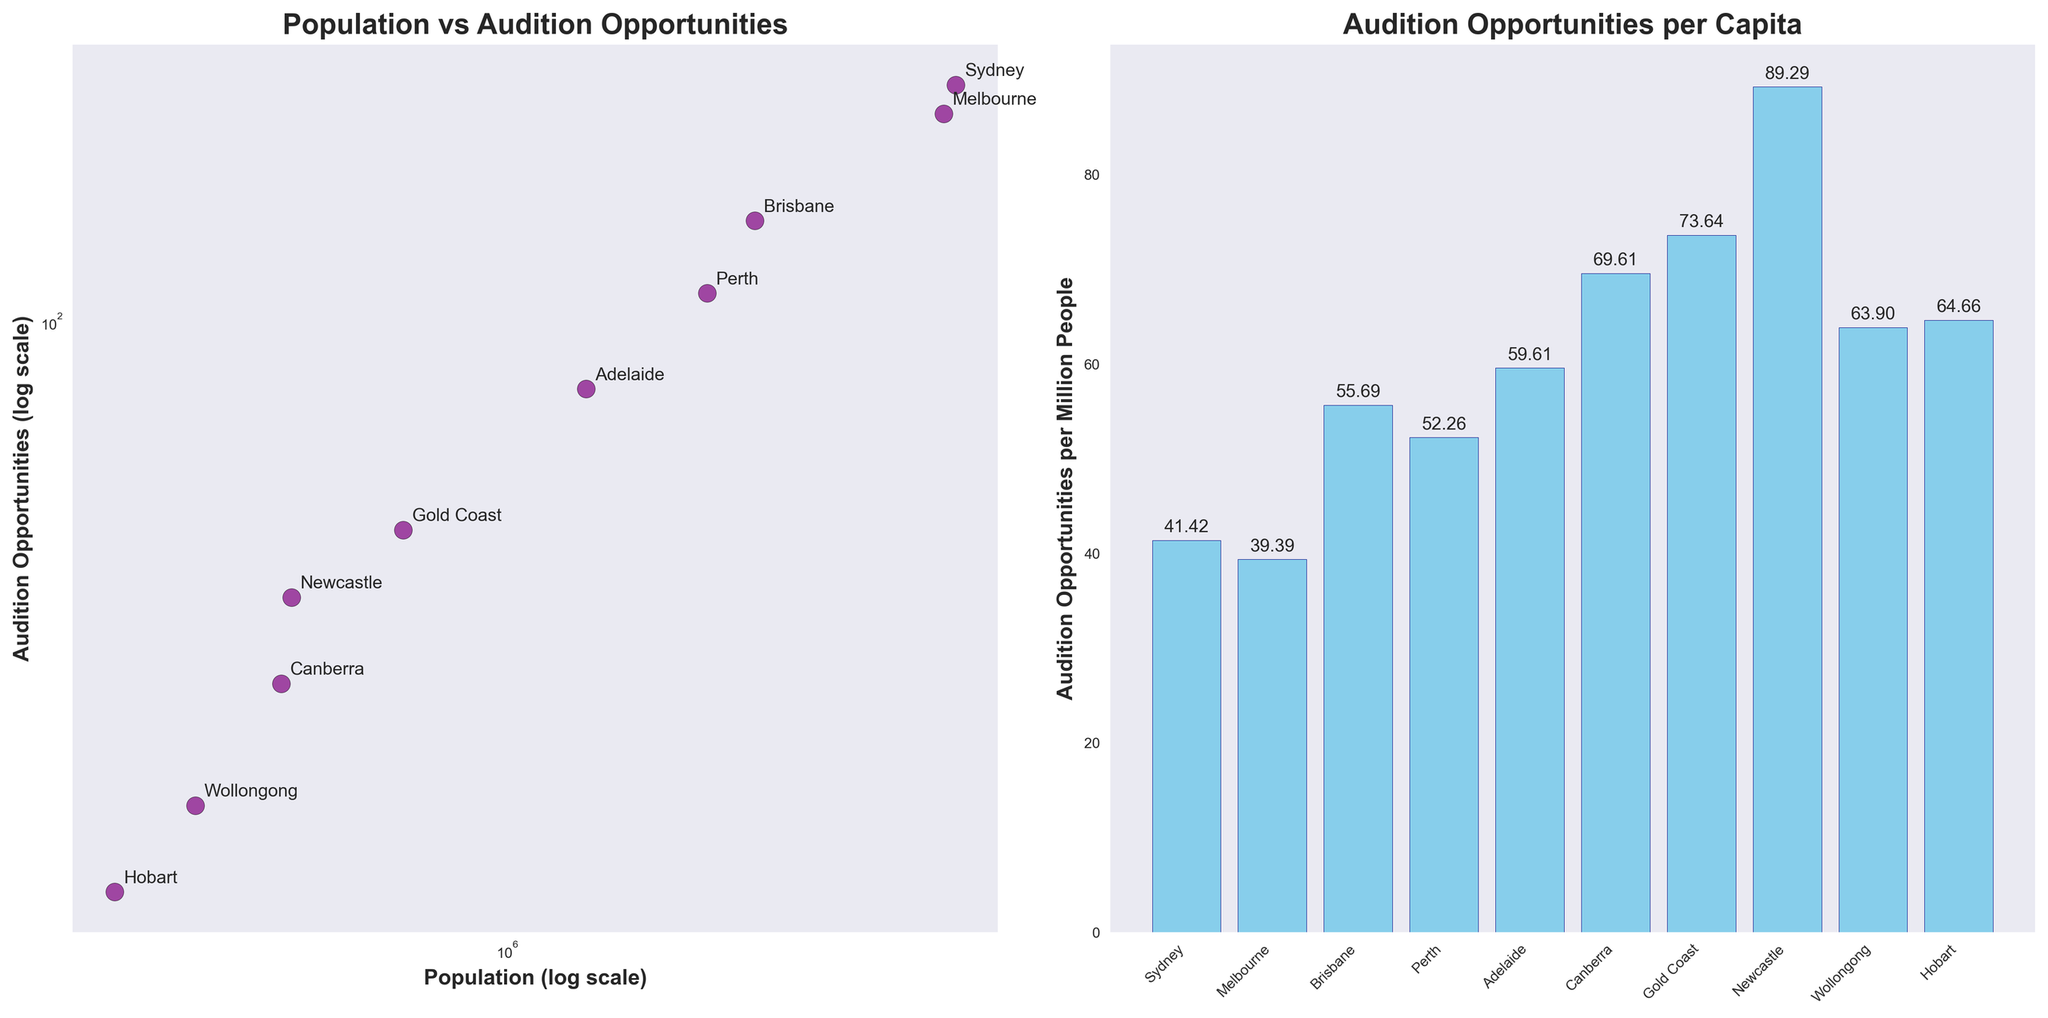Which city has the highest population? The left subplot shows population on the x-axis. From the data points, Sydney has the highest population by being furthest to the right.
Answer: Sydney How many cities have more than 100 audition opportunities? The left subplot uses a log scale. The cities above 100 on the y-axis are Sydney, Melbourne, Brisbane, and Perth.
Answer: 4 Which city has the highest auditions per capita? The right subplot shows audition opportunities per capita. Canberra has the highest bar, indicating the highest auditions per capita.
Answer: Canberra Which city has the lowest audition opportunities per capita? The right subplot indicates Hobart has the shortest bar, indicating the lowest auditions per capita.
Answer: Hobart What are the axes titles in the left subplot? The x-axis title is 'Population (log scale)', and the y-axis title is 'Audition Opportunities (log scale)'.
Answer: Population (log scale), Audition Opportunities (log scale) Which city lies next to Canberra in terms of auditions per capita? In the right subplot, Gold Coast is the next bar after Canberra in terms of height.
Answer: Gold Coast What is the y-value of Sydney in the left subplot? In the left subplot, find Sydney's marked point and look at its y-coordinate. Sydney has approximately 220 audition opportunities.
Answer: 220 How does Adelaide compare to Gold Coast in terms of audition opportunities and population? In the left subplot, Adelaide has fewer audition opportunities than Gold Coast (80 vs 50). However, Adelaide has a higher population than Gold Coast.
Answer: Adelaide has fewer auditions but a higher population Explain how the log scale helps in visualizing the population vs audition opportunities. The log scale compresses large ranges of values, making it easier to visualize differences between smaller and larger cities. Without the log scale, differences in large populations would overshadow smaller differences.
Answer: Compresses large ranges, easier visualization Are there any cities with roughly equal populations but very different audition opportunities? On the left subplot, comparing closely positioned points horizontally reveals Brisbane and Perth have similar populations but different audition opportunities (140 vs 110).
Answer: Brisbane and Perth 